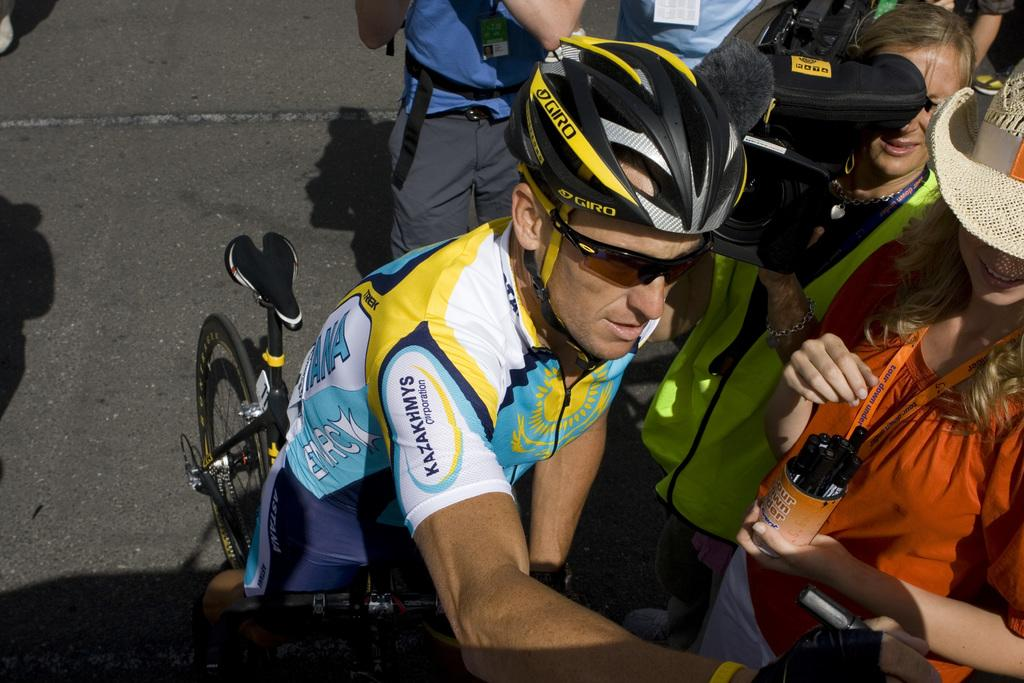Who is the main subject in the image? There is a man in the image. What is the man wearing? The man is wearing a sports dress. What activity is the man engaged in? The man is on a bicycle. What are the people on the right side of the image doing? The people are taking pictures of the man on the bicycle using cameras. Can you see the man's toes in the image? There is no indication of the man's toes being visible in the image. Who is the man's partner in the image? There is no mention of a partner in the image; it only shows the man on a bicycle and people taking pictures. 